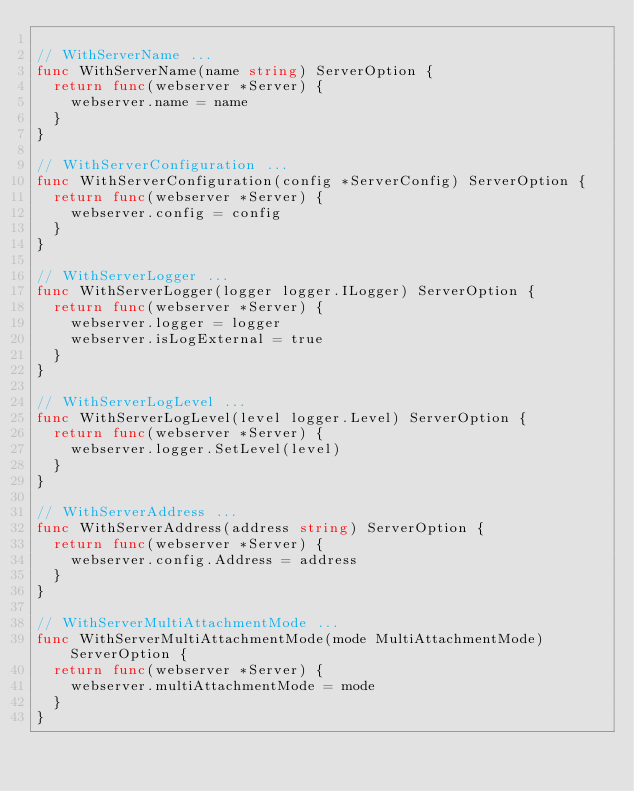<code> <loc_0><loc_0><loc_500><loc_500><_Go_>
// WithServerName ...
func WithServerName(name string) ServerOption {
	return func(webserver *Server) {
		webserver.name = name
	}
}

// WithServerConfiguration ...
func WithServerConfiguration(config *ServerConfig) ServerOption {
	return func(webserver *Server) {
		webserver.config = config
	}
}

// WithServerLogger ...
func WithServerLogger(logger logger.ILogger) ServerOption {
	return func(webserver *Server) {
		webserver.logger = logger
		webserver.isLogExternal = true
	}
}

// WithServerLogLevel ...
func WithServerLogLevel(level logger.Level) ServerOption {
	return func(webserver *Server) {
		webserver.logger.SetLevel(level)
	}
}

// WithServerAddress ...
func WithServerAddress(address string) ServerOption {
	return func(webserver *Server) {
		webserver.config.Address = address
	}
}

// WithServerMultiAttachmentMode ...
func WithServerMultiAttachmentMode(mode MultiAttachmentMode) ServerOption {
	return func(webserver *Server) {
		webserver.multiAttachmentMode = mode
	}
}
</code> 